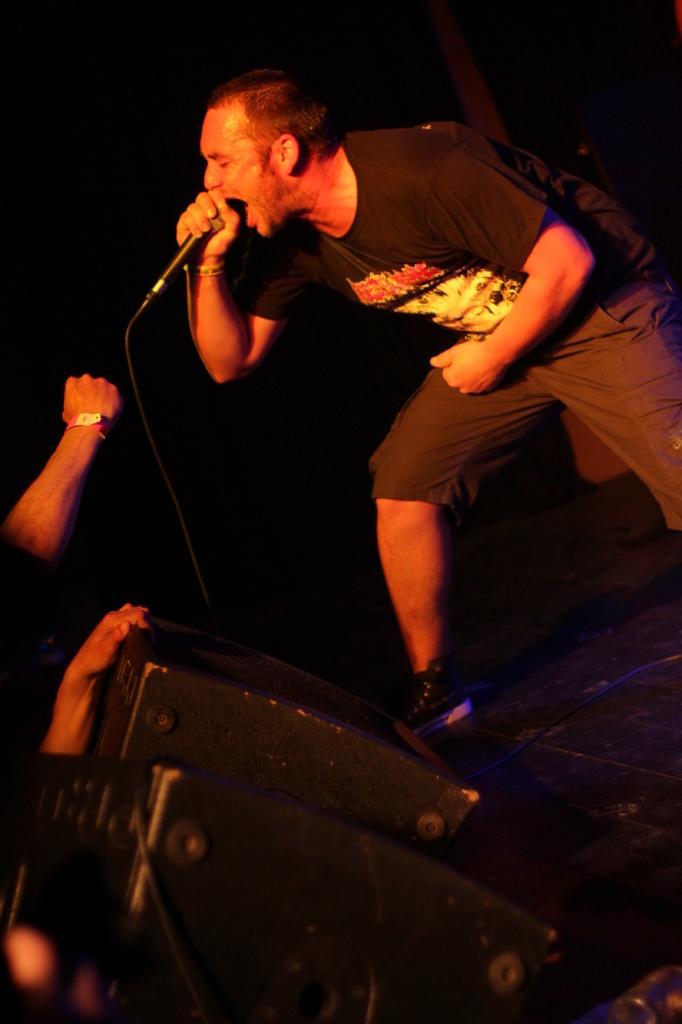Could you give a brief overview of what you see in this image? In this picture there is a man holding a microphone and singing and we can see devices and cables. In the background of the image it is dark. On the left side of the image we can see hands of persons. 